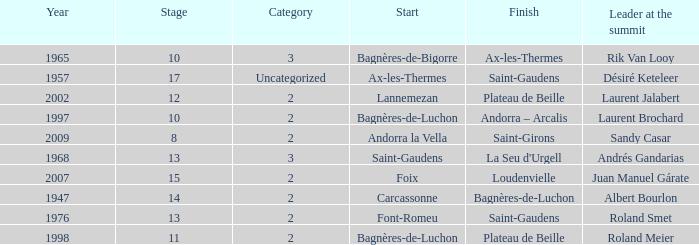Name the start of an event in Catagory 2 of the year 1947. Carcassonne. 